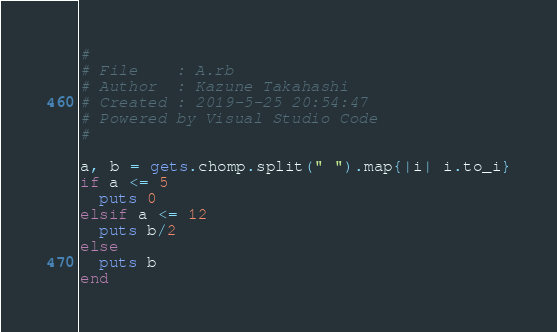Convert code to text. <code><loc_0><loc_0><loc_500><loc_500><_Ruby_>#
# File    : A.rb
# Author  : Kazune Takahashi
# Created : 2019-5-25 20:54:47
# Powered by Visual Studio Code
#

a, b = gets.chomp.split(" ").map{|i| i.to_i}
if a <= 5
  puts 0
elsif a <= 12
  puts b/2
else
  puts b
end</code> 